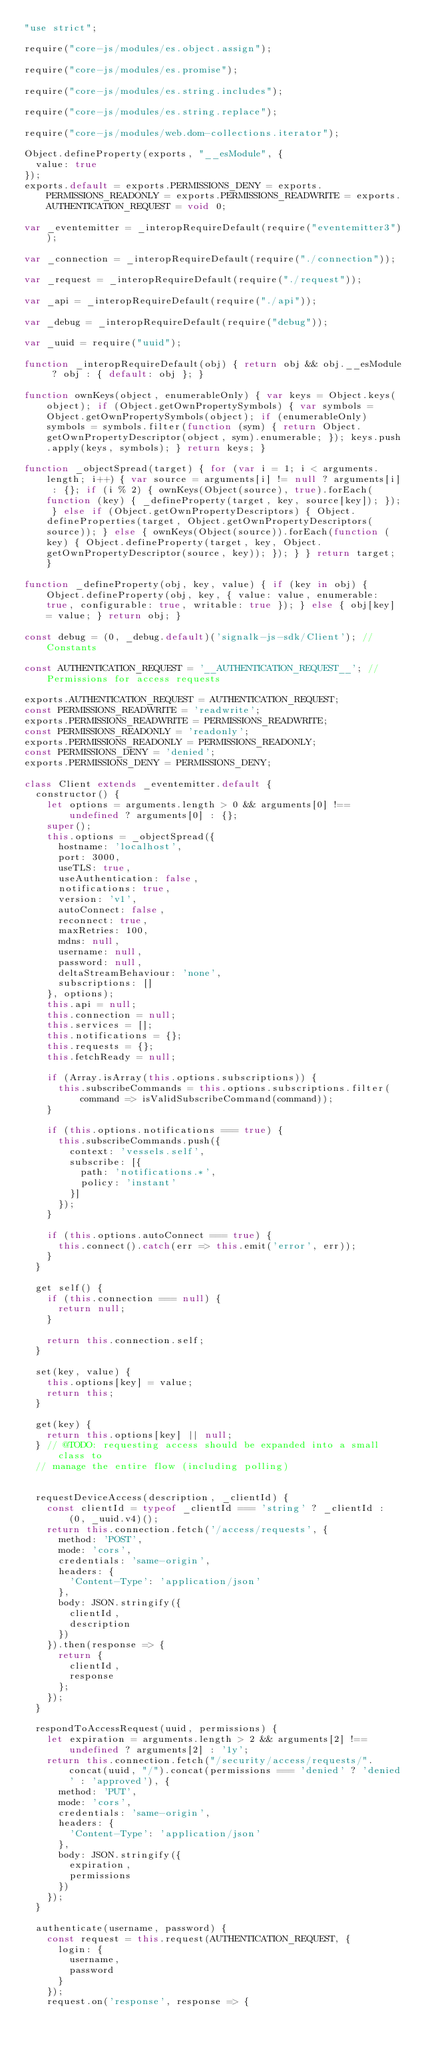<code> <loc_0><loc_0><loc_500><loc_500><_JavaScript_>"use strict";

require("core-js/modules/es.object.assign");

require("core-js/modules/es.promise");

require("core-js/modules/es.string.includes");

require("core-js/modules/es.string.replace");

require("core-js/modules/web.dom-collections.iterator");

Object.defineProperty(exports, "__esModule", {
  value: true
});
exports.default = exports.PERMISSIONS_DENY = exports.PERMISSIONS_READONLY = exports.PERMISSIONS_READWRITE = exports.AUTHENTICATION_REQUEST = void 0;

var _eventemitter = _interopRequireDefault(require("eventemitter3"));

var _connection = _interopRequireDefault(require("./connection"));

var _request = _interopRequireDefault(require("./request"));

var _api = _interopRequireDefault(require("./api"));

var _debug = _interopRequireDefault(require("debug"));

var _uuid = require("uuid");

function _interopRequireDefault(obj) { return obj && obj.__esModule ? obj : { default: obj }; }

function ownKeys(object, enumerableOnly) { var keys = Object.keys(object); if (Object.getOwnPropertySymbols) { var symbols = Object.getOwnPropertySymbols(object); if (enumerableOnly) symbols = symbols.filter(function (sym) { return Object.getOwnPropertyDescriptor(object, sym).enumerable; }); keys.push.apply(keys, symbols); } return keys; }

function _objectSpread(target) { for (var i = 1; i < arguments.length; i++) { var source = arguments[i] != null ? arguments[i] : {}; if (i % 2) { ownKeys(Object(source), true).forEach(function (key) { _defineProperty(target, key, source[key]); }); } else if (Object.getOwnPropertyDescriptors) { Object.defineProperties(target, Object.getOwnPropertyDescriptors(source)); } else { ownKeys(Object(source)).forEach(function (key) { Object.defineProperty(target, key, Object.getOwnPropertyDescriptor(source, key)); }); } } return target; }

function _defineProperty(obj, key, value) { if (key in obj) { Object.defineProperty(obj, key, { value: value, enumerable: true, configurable: true, writable: true }); } else { obj[key] = value; } return obj; }

const debug = (0, _debug.default)('signalk-js-sdk/Client'); // Constants

const AUTHENTICATION_REQUEST = '__AUTHENTICATION_REQUEST__'; // Permissions for access requests

exports.AUTHENTICATION_REQUEST = AUTHENTICATION_REQUEST;
const PERMISSIONS_READWRITE = 'readwrite';
exports.PERMISSIONS_READWRITE = PERMISSIONS_READWRITE;
const PERMISSIONS_READONLY = 'readonly';
exports.PERMISSIONS_READONLY = PERMISSIONS_READONLY;
const PERMISSIONS_DENY = 'denied';
exports.PERMISSIONS_DENY = PERMISSIONS_DENY;

class Client extends _eventemitter.default {
  constructor() {
    let options = arguments.length > 0 && arguments[0] !== undefined ? arguments[0] : {};
    super();
    this.options = _objectSpread({
      hostname: 'localhost',
      port: 3000,
      useTLS: true,
      useAuthentication: false,
      notifications: true,
      version: 'v1',
      autoConnect: false,
      reconnect: true,
      maxRetries: 100,
      mdns: null,
      username: null,
      password: null,
      deltaStreamBehaviour: 'none',
      subscriptions: []
    }, options);
    this.api = null;
    this.connection = null;
    this.services = [];
    this.notifications = {};
    this.requests = {};
    this.fetchReady = null;

    if (Array.isArray(this.options.subscriptions)) {
      this.subscribeCommands = this.options.subscriptions.filter(command => isValidSubscribeCommand(command));
    }

    if (this.options.notifications === true) {
      this.subscribeCommands.push({
        context: 'vessels.self',
        subscribe: [{
          path: 'notifications.*',
          policy: 'instant'
        }]
      });
    }

    if (this.options.autoConnect === true) {
      this.connect().catch(err => this.emit('error', err));
    }
  }

  get self() {
    if (this.connection === null) {
      return null;
    }

    return this.connection.self;
  }

  set(key, value) {
    this.options[key] = value;
    return this;
  }

  get(key) {
    return this.options[key] || null;
  } // @TODO: requesting access should be expanded into a small class to
  // manage the entire flow (including polling)


  requestDeviceAccess(description, _clientId) {
    const clientId = typeof _clientId === 'string' ? _clientId : (0, _uuid.v4)();
    return this.connection.fetch('/access/requests', {
      method: 'POST',
      mode: 'cors',
      credentials: 'same-origin',
      headers: {
        'Content-Type': 'application/json'
      },
      body: JSON.stringify({
        clientId,
        description
      })
    }).then(response => {
      return {
        clientId,
        response
      };
    });
  }

  respondToAccessRequest(uuid, permissions) {
    let expiration = arguments.length > 2 && arguments[2] !== undefined ? arguments[2] : '1y';
    return this.connection.fetch("/security/access/requests/".concat(uuid, "/").concat(permissions === 'denied' ? 'denied' : 'approved'), {
      method: 'PUT',
      mode: 'cors',
      credentials: 'same-origin',
      headers: {
        'Content-Type': 'application/json'
      },
      body: JSON.stringify({
        expiration,
        permissions
      })
    });
  }

  authenticate(username, password) {
    const request = this.request(AUTHENTICATION_REQUEST, {
      login: {
        username,
        password
      }
    });
    request.on('response', response => {</code> 